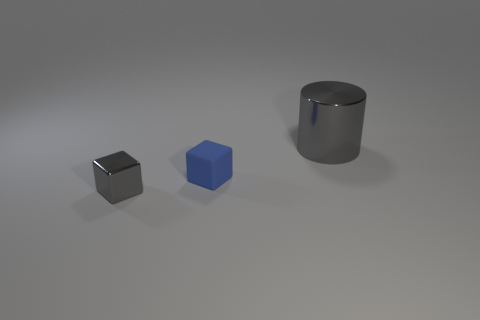Subtract all cubes. How many objects are left? 1 Subtract 0 brown cubes. How many objects are left? 3 Subtract 2 blocks. How many blocks are left? 0 Subtract all gray cubes. Subtract all yellow cylinders. How many cubes are left? 1 Subtract all red balls. How many gray cubes are left? 1 Subtract all blue cylinders. Subtract all large gray shiny objects. How many objects are left? 2 Add 2 cubes. How many cubes are left? 4 Add 3 big cyan shiny things. How many big cyan shiny things exist? 3 Add 2 gray rubber balls. How many objects exist? 5 Subtract all blue cubes. How many cubes are left? 1 